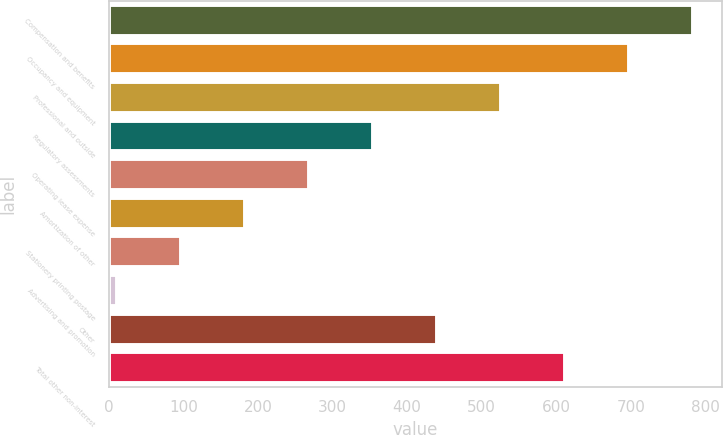Convert chart to OTSL. <chart><loc_0><loc_0><loc_500><loc_500><bar_chart><fcel>Compensation and benefits<fcel>Occupancy and equipment<fcel>Professional and outside<fcel>Regulatory assessments<fcel>Operating lease expense<fcel>Amortization of other<fcel>Stationery printing postage<fcel>Advertising and promotion<fcel>Other<fcel>Total other non-interest<nl><fcel>783.04<fcel>697.28<fcel>525.76<fcel>354.24<fcel>268.48<fcel>182.72<fcel>96.96<fcel>11.2<fcel>440<fcel>611.52<nl></chart> 